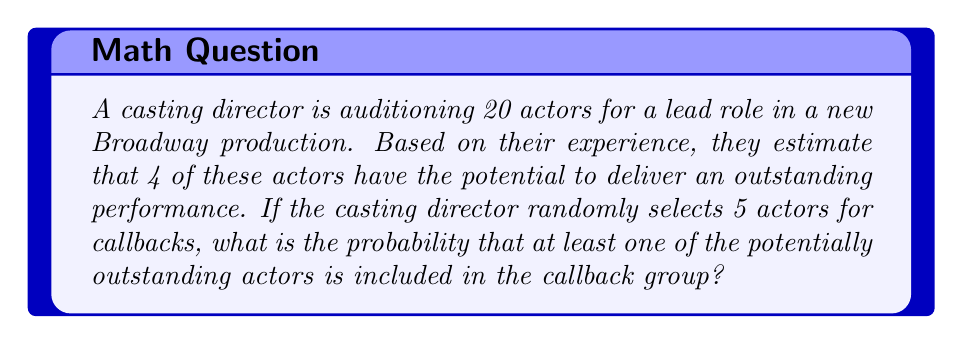Can you answer this question? Let's approach this step-by-step:

1) First, we need to calculate the probability of the complement event: selecting 5 actors with none of them being from the 4 outstanding ones.

2) This can be calculated using the hypergeometric distribution:

   $P(\text{no outstanding actors}) = \frac{\binom{16}{5}}{\binom{20}{5}}$

3) Where:
   - 16 is the number of non-outstanding actors
   - 5 is the number of actors selected for callbacks
   - 20 is the total number of actors auditioning

4) Let's calculate this:

   $\binom{16}{5} = 4368$
   $\binom{20}{5} = 15504$

   $P(\text{no outstanding actors}) = \frac{4368}{15504} = \frac{273}{969} \approx 0.2817$

5) The probability we're looking for is the complement of this:

   $P(\text{at least one outstanding actor}) = 1 - P(\text{no outstanding actors})$

6) Therefore:

   $P(\text{at least one outstanding actor}) = 1 - \frac{273}{969} = \frac{696}{969} \approx 0.7183$

7) Converting to a percentage:

   $0.7183 \times 100\% \approx 71.83\%$
Answer: $71.83\%$ 